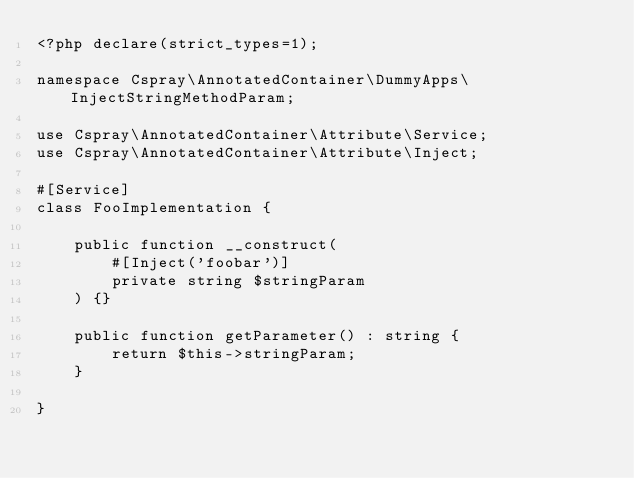<code> <loc_0><loc_0><loc_500><loc_500><_PHP_><?php declare(strict_types=1);

namespace Cspray\AnnotatedContainer\DummyApps\InjectStringMethodParam;

use Cspray\AnnotatedContainer\Attribute\Service;
use Cspray\AnnotatedContainer\Attribute\Inject;

#[Service]
class FooImplementation {

    public function __construct(
        #[Inject('foobar')]
        private string $stringParam
    ) {}

    public function getParameter() : string {
        return $this->stringParam;
    }

}</code> 